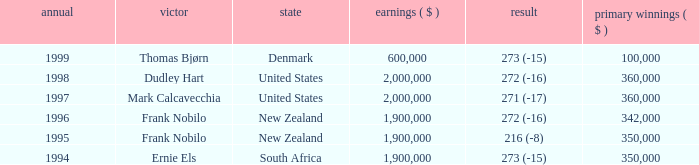What was the top first place prize in 1997? 360000.0. 